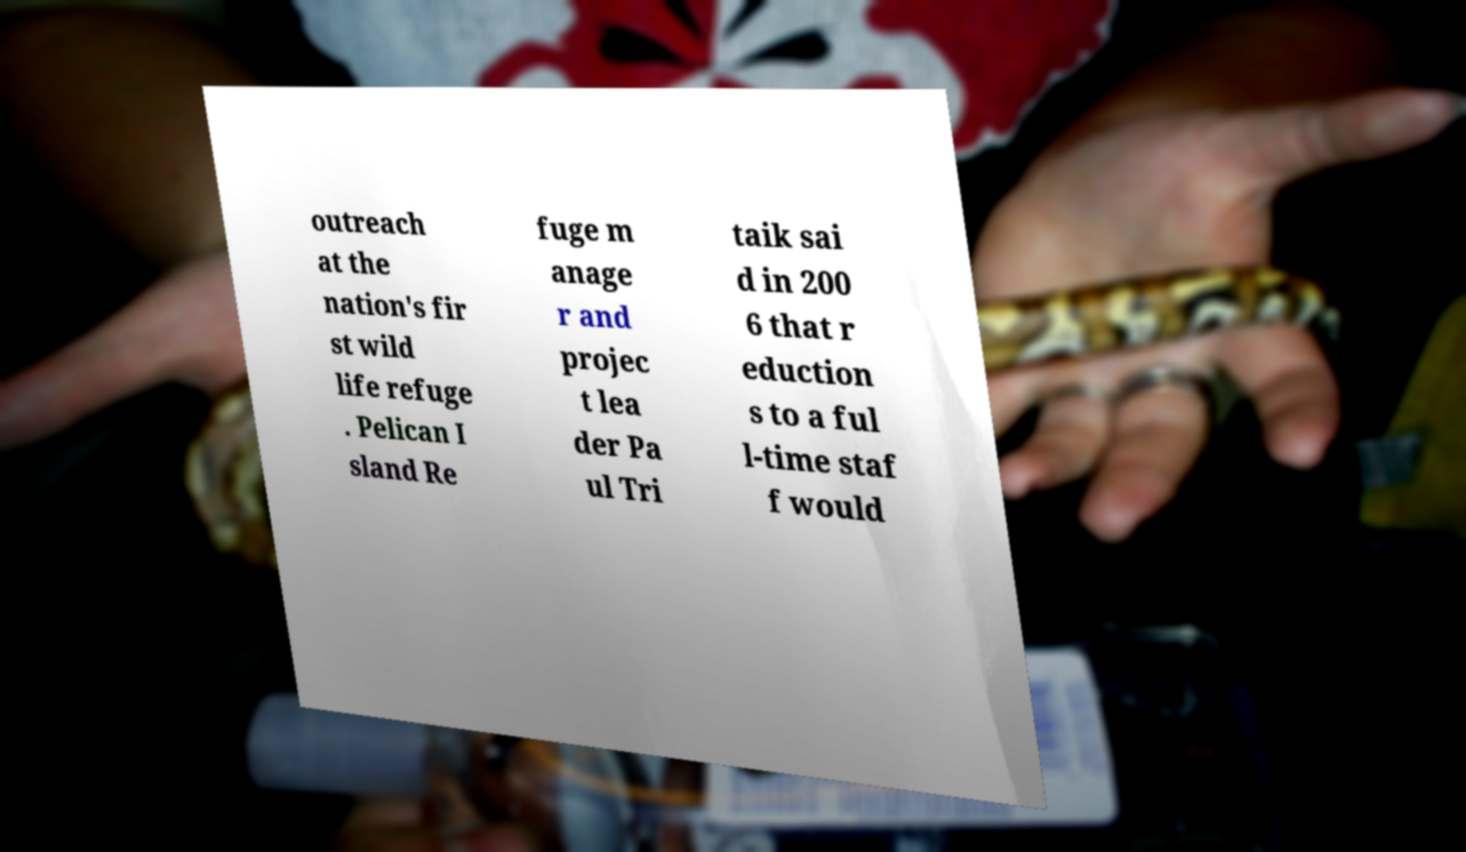Please read and relay the text visible in this image. What does it say? outreach at the nation's fir st wild life refuge . Pelican I sland Re fuge m anage r and projec t lea der Pa ul Tri taik sai d in 200 6 that r eduction s to a ful l-time staf f would 